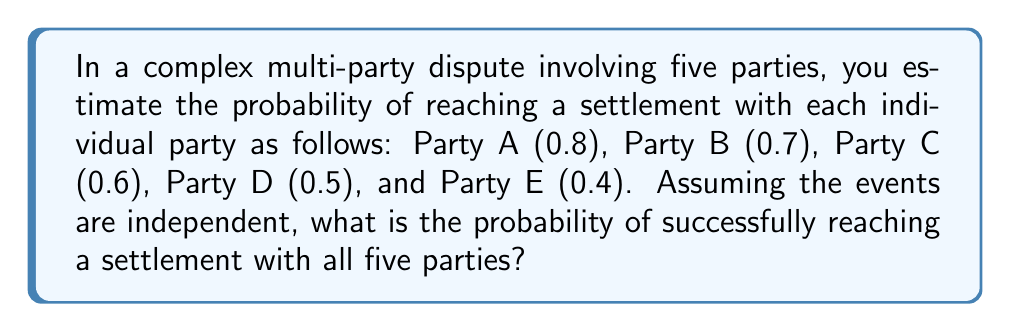Could you help me with this problem? To solve this problem, we need to follow these steps:

1. Recognize that we need all parties to settle for a complete resolution.
2. Use the multiplication rule of probability for independent events.

The probability of all independent events occurring together is the product of their individual probabilities.

Let's define the events:
$A$: settling with Party A
$B$: settling with Party B
$C$: settling with Party C
$D$: settling with Party D
$E$: settling with Party E

We want to find $P(A \cap B \cap C \cap D \cap E)$

Given:
$P(A) = 0.8$
$P(B) = 0.7$
$P(C) = 0.6$
$P(D) = 0.5$
$P(E) = 0.4$

Using the multiplication rule:

$$P(A \cap B \cap C \cap D \cap E) = P(A) \times P(B) \times P(C) \times P(D) \times P(E)$$

Substituting the values:

$$P(A \cap B \cap C \cap D \cap E) = 0.8 \times 0.7 \times 0.6 \times 0.5 \times 0.4$$

$$P(A \cap B \cap C \cap D \cap E) = 0.0672$$

Convert to a percentage:

$$0.0672 \times 100\% = 6.72\%$$
Answer: 6.72% 